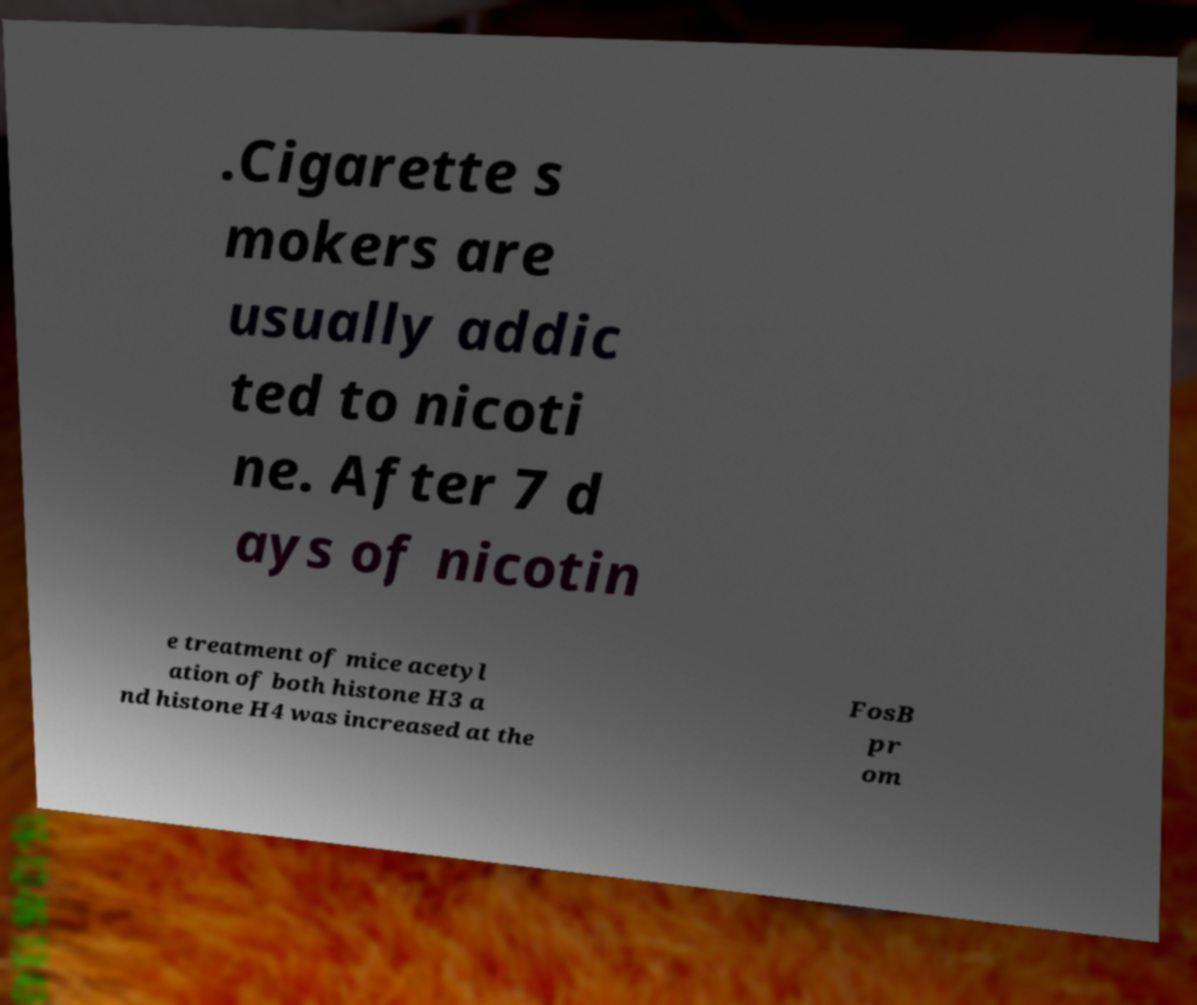Can you read and provide the text displayed in the image?This photo seems to have some interesting text. Can you extract and type it out for me? .Cigarette s mokers are usually addic ted to nicoti ne. After 7 d ays of nicotin e treatment of mice acetyl ation of both histone H3 a nd histone H4 was increased at the FosB pr om 